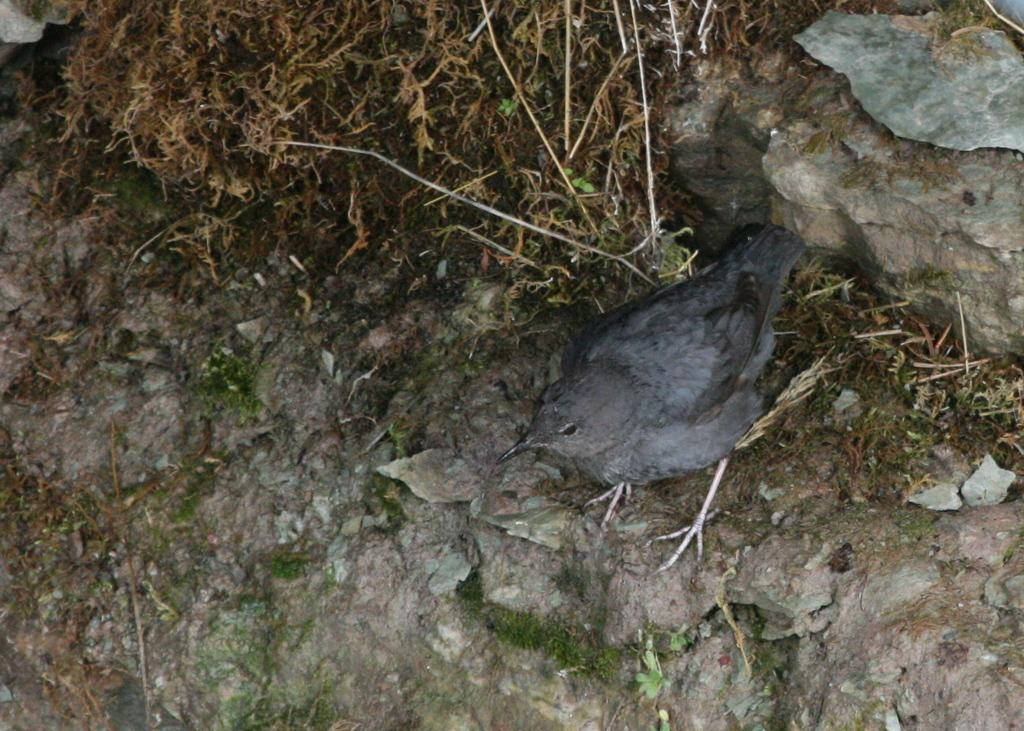What type of animal can be seen in the image? There is a bird in the image. What else is present in the image besides the bird? There are dried plants in the image. How does the bird control the mass of the dried plants in the image? The bird does not control the mass of the dried plants in the image; it is simply perched among them. 